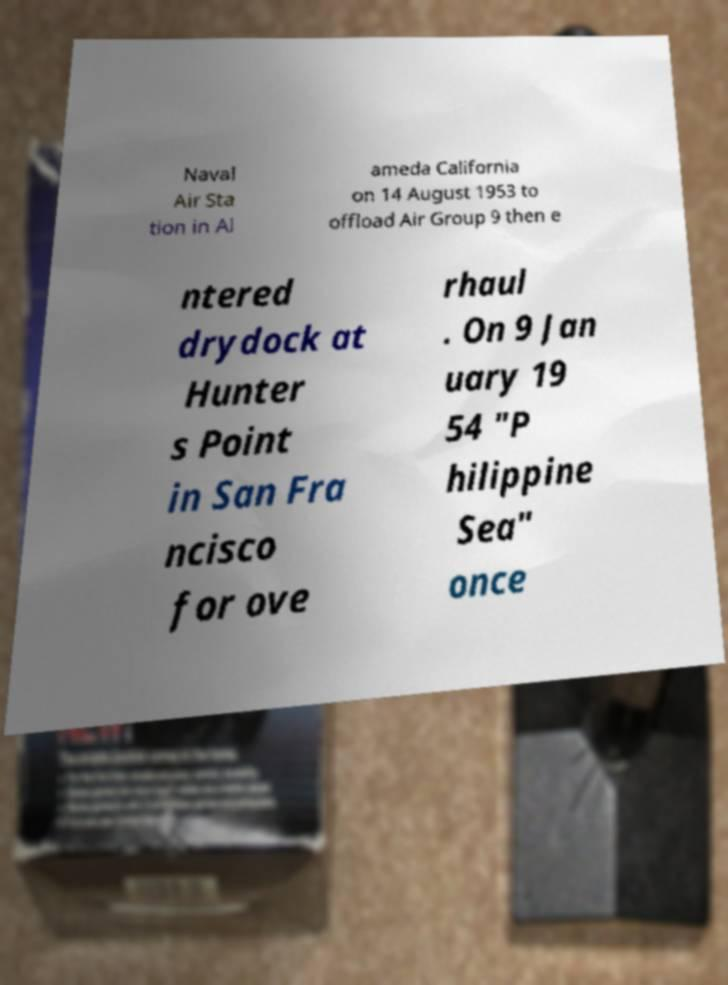Can you read and provide the text displayed in the image?This photo seems to have some interesting text. Can you extract and type it out for me? Naval Air Sta tion in Al ameda California on 14 August 1953 to offload Air Group 9 then e ntered drydock at Hunter s Point in San Fra ncisco for ove rhaul . On 9 Jan uary 19 54 "P hilippine Sea" once 